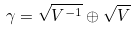Convert formula to latex. <formula><loc_0><loc_0><loc_500><loc_500>\gamma = \sqrt { V ^ { - 1 } } \oplus \sqrt { V }</formula> 